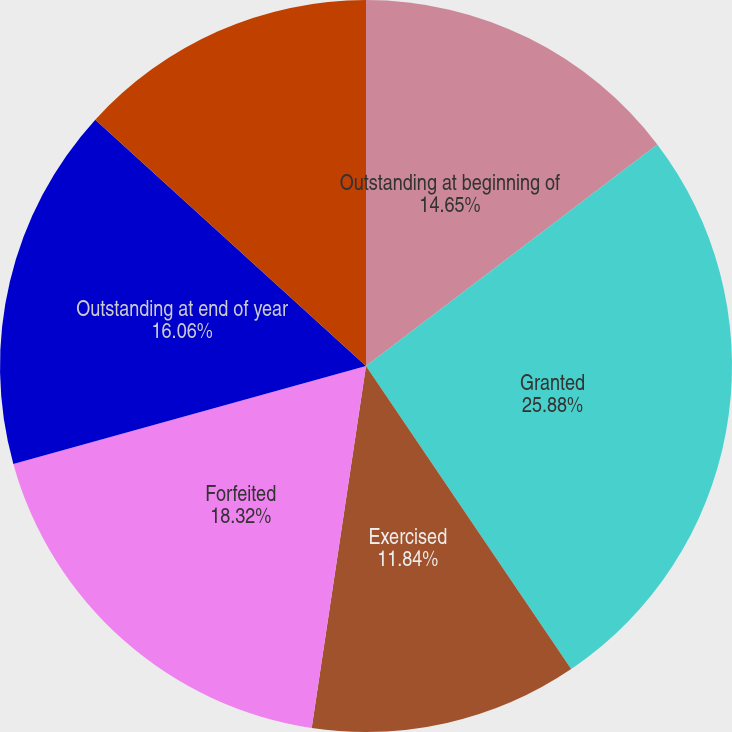Convert chart. <chart><loc_0><loc_0><loc_500><loc_500><pie_chart><fcel>Outstanding at beginning of<fcel>Granted<fcel>Exercised<fcel>Forfeited<fcel>Outstanding at end of year<fcel>Options exercisable at<nl><fcel>14.65%<fcel>25.88%<fcel>11.84%<fcel>18.32%<fcel>16.06%<fcel>13.25%<nl></chart> 